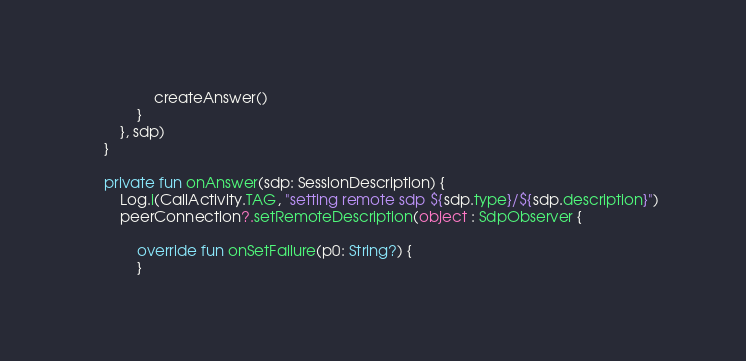Convert code to text. <code><loc_0><loc_0><loc_500><loc_500><_Kotlin_>                createAnswer()
            }
        }, sdp)
    }

    private fun onAnswer(sdp: SessionDescription) {
        Log.i(CallActivity.TAG, "setting remote sdp ${sdp.type}/${sdp.description}")
        peerConnection?.setRemoteDescription(object : SdpObserver {

            override fun onSetFailure(p0: String?) {
            }
</code> 